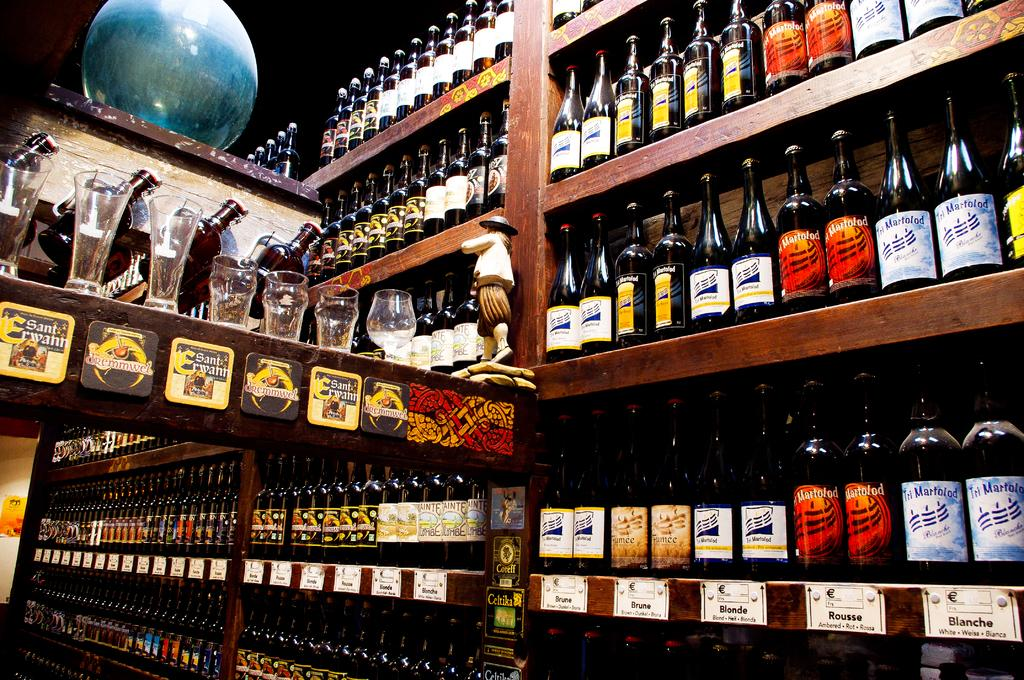What types of containers are present in the image? There are bottles and glasses in the image. What other objects can be seen in the image besides containers? There is a ball and a doll in the image. What type of box is used to store the approval in the image? There is no box or approval present in the image. 